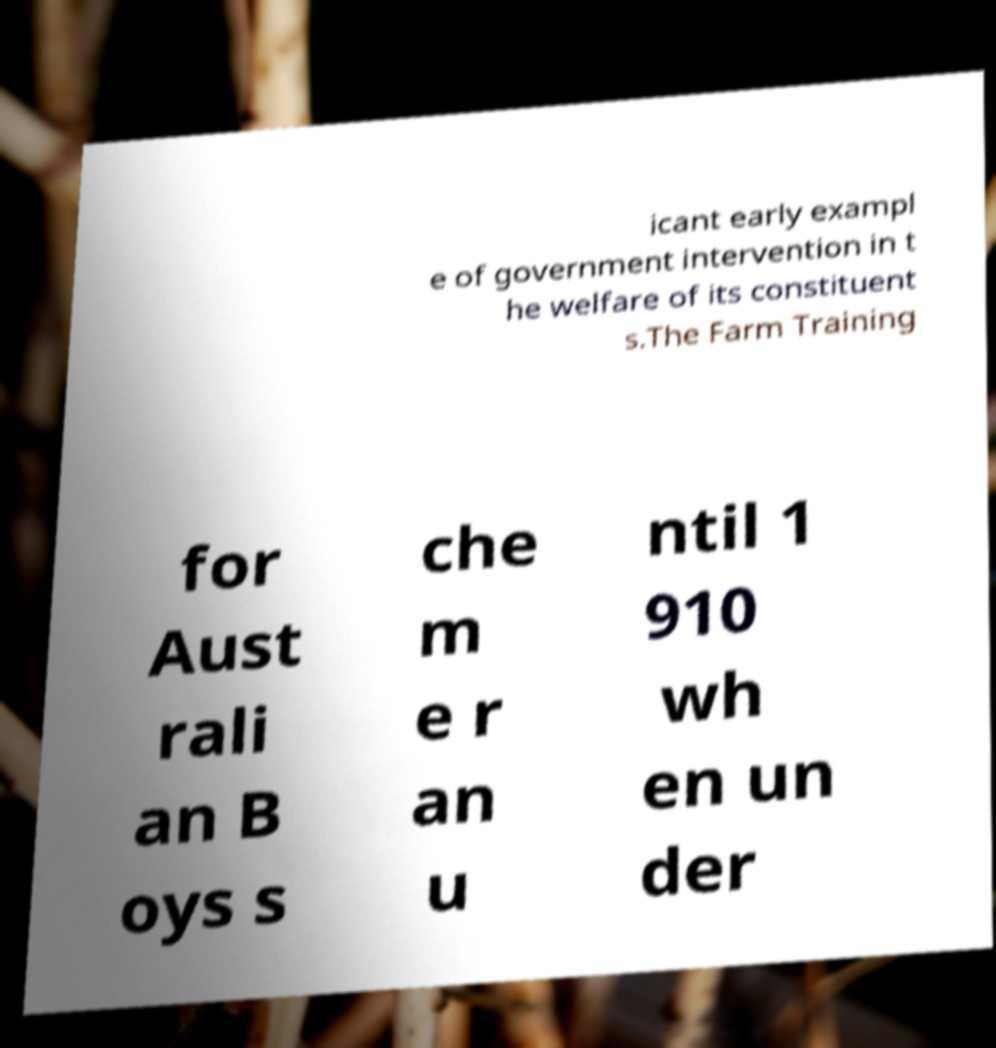Please identify and transcribe the text found in this image. icant early exampl e of government intervention in t he welfare of its constituent s.The Farm Training for Aust rali an B oys s che m e r an u ntil 1 910 wh en un der 